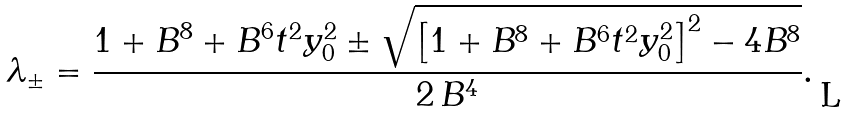<formula> <loc_0><loc_0><loc_500><loc_500>\lambda _ { \pm } = \frac { 1 + B ^ { 8 } + B ^ { 6 } t ^ { 2 } y _ { 0 } ^ { 2 } \pm \sqrt { \left [ 1 + B ^ { 8 } + B ^ { 6 } t ^ { 2 } y _ { 0 } ^ { 2 } \right ] ^ { 2 } - 4 B ^ { 8 } } } { 2 \, B ^ { 4 } } .</formula> 